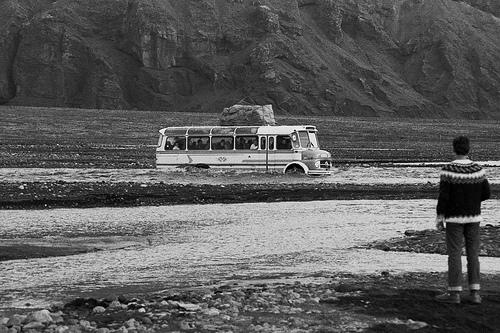Create a short narrative about the situation shown in the image. As the vintage bus carefully navigates its way through the water, carrying passengers and luggage, a man with rolled-up pants and a patterned sweater watches intently from the rocky shore. Create a sentence that describes the main subject in the image and details any noteworthy items they are wearing or carrying. A man, wearing a patterned sweater and dark rolled-up pants, stands on a rocky shore while watching a bus with passengers and roof cargo drive through water. Compose an image caption highlighting the type of terrain shown and the interaction between the man and the bus. On a rocky waterfront with a hill in the distance, a man sporting a patterned sweater and rolled-up pants watches a bus full of passengers and luggage traverse through water. Identify and describe the primary mode of transportation present in the image. The primary mode of transportation in the image is an old white bus that is driving through water and carrying passengers and cargo on its roof. Provide an overview of the image, focusing on the clothing worn by the man and the condition of the bus. A man with a patterned sweater, rolled-up pants, and short dark hair observes an old, white bus driving through water, carrying people and luggage. Describe the scene by focusing on the interaction or relationship between the main subjects. As the bus drives through water with its passengers, luggage, and a rocky backdrop, a man in a patterned sweater and rolled-up pants carefully observes the scene. Write a brief description focusing on the central action taking place in the image. A bus is driving through water with people on it while a man watches nearby, standing on a rocky shore. Summarize the key elements in the image, including any notable objects or people. The image features an old bus driving through water with cargo on its roof, people inside, and a man in a patterned sweater observing from the rocky shoreline. Describe the environment or landscape where the main action is taking place in the image. The main action takes place near a rocky shore with a hill in the background, where a bus is navigating through water while a man observes. Briefly describe the primary point of interest in the image and the person observing it. A bus carrying passengers and luggage navigates through water as a man dressed in a patterned sweater and rolled-up pants watches from the rocky shoreline. 